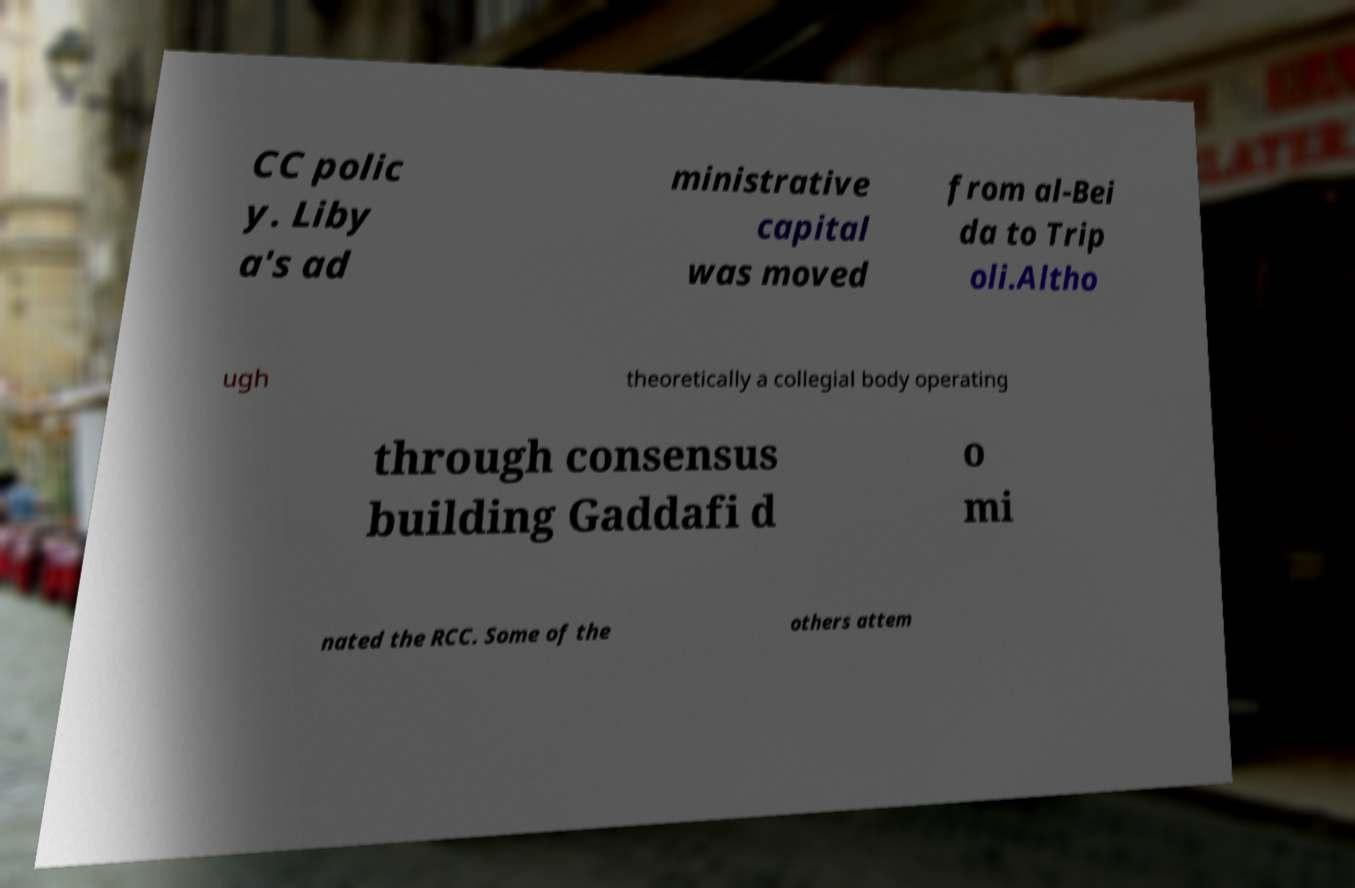I need the written content from this picture converted into text. Can you do that? CC polic y. Liby a's ad ministrative capital was moved from al-Bei da to Trip oli.Altho ugh theoretically a collegial body operating through consensus building Gaddafi d o mi nated the RCC. Some of the others attem 